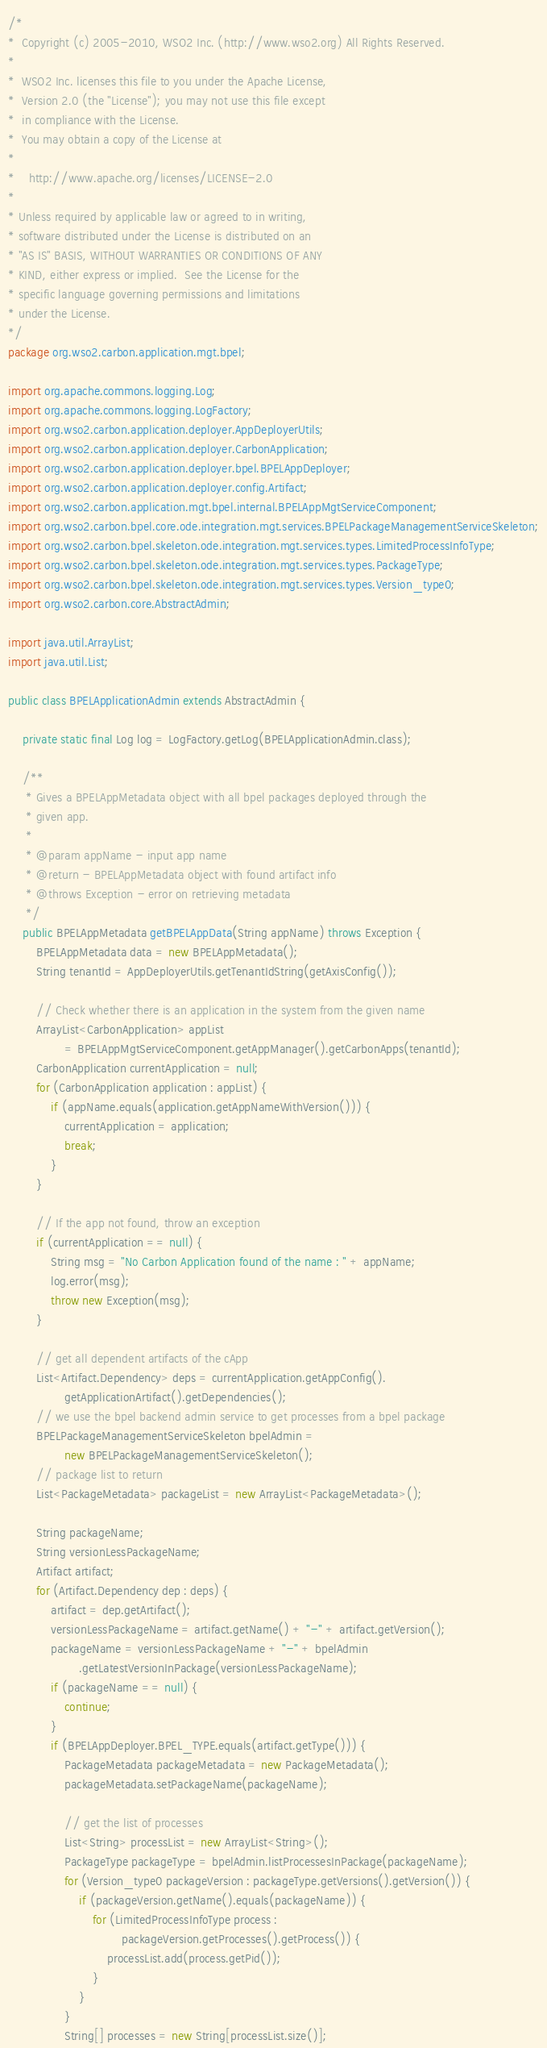Convert code to text. <code><loc_0><loc_0><loc_500><loc_500><_Java_>/*
*  Copyright (c) 2005-2010, WSO2 Inc. (http://www.wso2.org) All Rights Reserved.
*
*  WSO2 Inc. licenses this file to you under the Apache License,
*  Version 2.0 (the "License"); you may not use this file except
*  in compliance with the License.
*  You may obtain a copy of the License at
*
*    http://www.apache.org/licenses/LICENSE-2.0
*
* Unless required by applicable law or agreed to in writing,
* software distributed under the License is distributed on an
* "AS IS" BASIS, WITHOUT WARRANTIES OR CONDITIONS OF ANY
* KIND, either express or implied.  See the License for the
* specific language governing permissions and limitations
* under the License.
*/
package org.wso2.carbon.application.mgt.bpel;

import org.apache.commons.logging.Log;
import org.apache.commons.logging.LogFactory;
import org.wso2.carbon.application.deployer.AppDeployerUtils;
import org.wso2.carbon.application.deployer.CarbonApplication;
import org.wso2.carbon.application.deployer.bpel.BPELAppDeployer;
import org.wso2.carbon.application.deployer.config.Artifact;
import org.wso2.carbon.application.mgt.bpel.internal.BPELAppMgtServiceComponent;
import org.wso2.carbon.bpel.core.ode.integration.mgt.services.BPELPackageManagementServiceSkeleton;
import org.wso2.carbon.bpel.skeleton.ode.integration.mgt.services.types.LimitedProcessInfoType;
import org.wso2.carbon.bpel.skeleton.ode.integration.mgt.services.types.PackageType;
import org.wso2.carbon.bpel.skeleton.ode.integration.mgt.services.types.Version_type0;
import org.wso2.carbon.core.AbstractAdmin;

import java.util.ArrayList;
import java.util.List;

public class BPELApplicationAdmin extends AbstractAdmin {

    private static final Log log = LogFactory.getLog(BPELApplicationAdmin.class);

    /**
     * Gives a BPELAppMetadata object with all bpel packages deployed through the
     * given app.
     *
     * @param appName - input app name
     * @return - BPELAppMetadata object with found artifact info
     * @throws Exception - error on retrieving metadata
     */
    public BPELAppMetadata getBPELAppData(String appName) throws Exception {
        BPELAppMetadata data = new BPELAppMetadata();
        String tenantId = AppDeployerUtils.getTenantIdString(getAxisConfig());

        // Check whether there is an application in the system from the given name
        ArrayList<CarbonApplication> appList
                = BPELAppMgtServiceComponent.getAppManager().getCarbonApps(tenantId);
        CarbonApplication currentApplication = null;
        for (CarbonApplication application : appList) {
            if (appName.equals(application.getAppNameWithVersion())) {
                currentApplication = application;
                break;
            }
        }

        // If the app not found, throw an exception
        if (currentApplication == null) {
            String msg = "No Carbon Application found of the name : " + appName;
            log.error(msg);
            throw new Exception(msg);
        }

        // get all dependent artifacts of the cApp
        List<Artifact.Dependency> deps = currentApplication.getAppConfig().
                getApplicationArtifact().getDependencies();
        // we use the bpel backend admin service to get processes from a bpel package
        BPELPackageManagementServiceSkeleton bpelAdmin =
                new BPELPackageManagementServiceSkeleton();
        // package list to return
        List<PackageMetadata> packageList = new ArrayList<PackageMetadata>();

        String packageName;
        String versionLessPackageName;
        Artifact artifact;
        for (Artifact.Dependency dep : deps) {
            artifact = dep.getArtifact();
            versionLessPackageName = artifact.getName() + "-" + artifact.getVersion();
            packageName = versionLessPackageName + "-" + bpelAdmin
                    .getLatestVersionInPackage(versionLessPackageName);
            if (packageName == null) {
                continue;
            }
            if (BPELAppDeployer.BPEL_TYPE.equals(artifact.getType())) {
                PackageMetadata packageMetadata = new PackageMetadata();
                packageMetadata.setPackageName(packageName);

                // get the list of processes
                List<String> processList = new ArrayList<String>();
                PackageType packageType = bpelAdmin.listProcessesInPackage(packageName);
                for (Version_type0 packageVersion : packageType.getVersions().getVersion()) {
                    if (packageVersion.getName().equals(packageName)) {
                        for (LimitedProcessInfoType process :
                                packageVersion.getProcesses().getProcess()) {
                            processList.add(process.getPid());
                        }
                    }
                }
                String[] processes = new String[processList.size()];</code> 